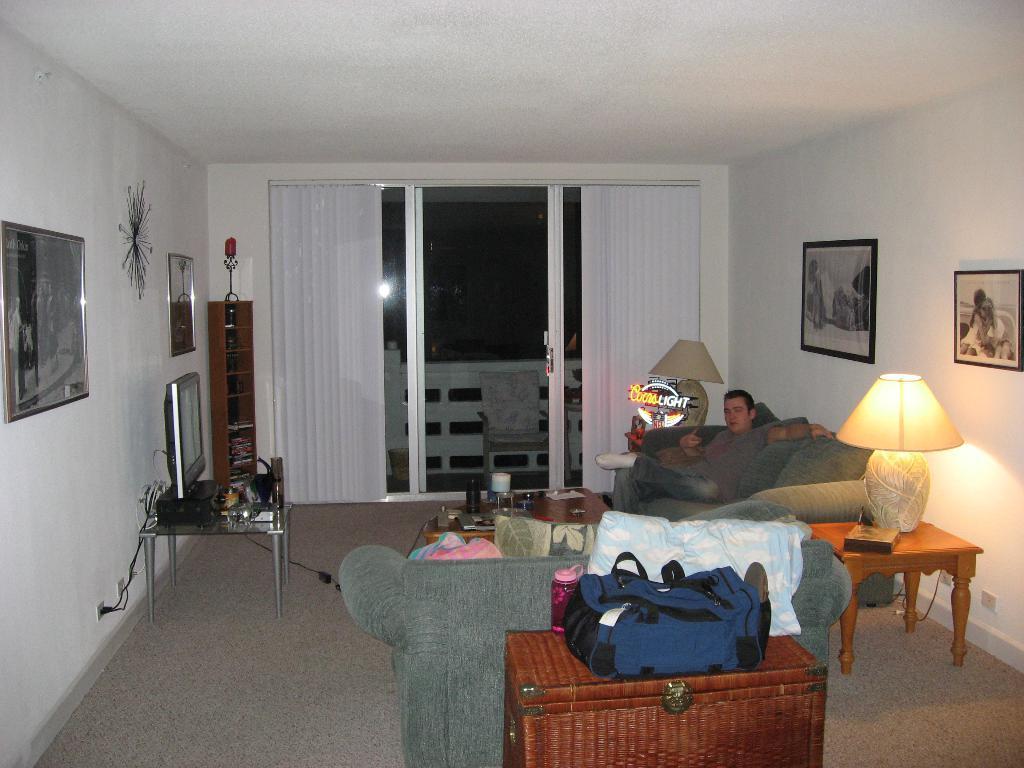Can you describe this image briefly? This picture shows a man seated on the sofa and we see blinds to the window and we see a backpack and a lamp on the table and we see a television and couple of photo frames on the wall and we see few classes and book on the table 